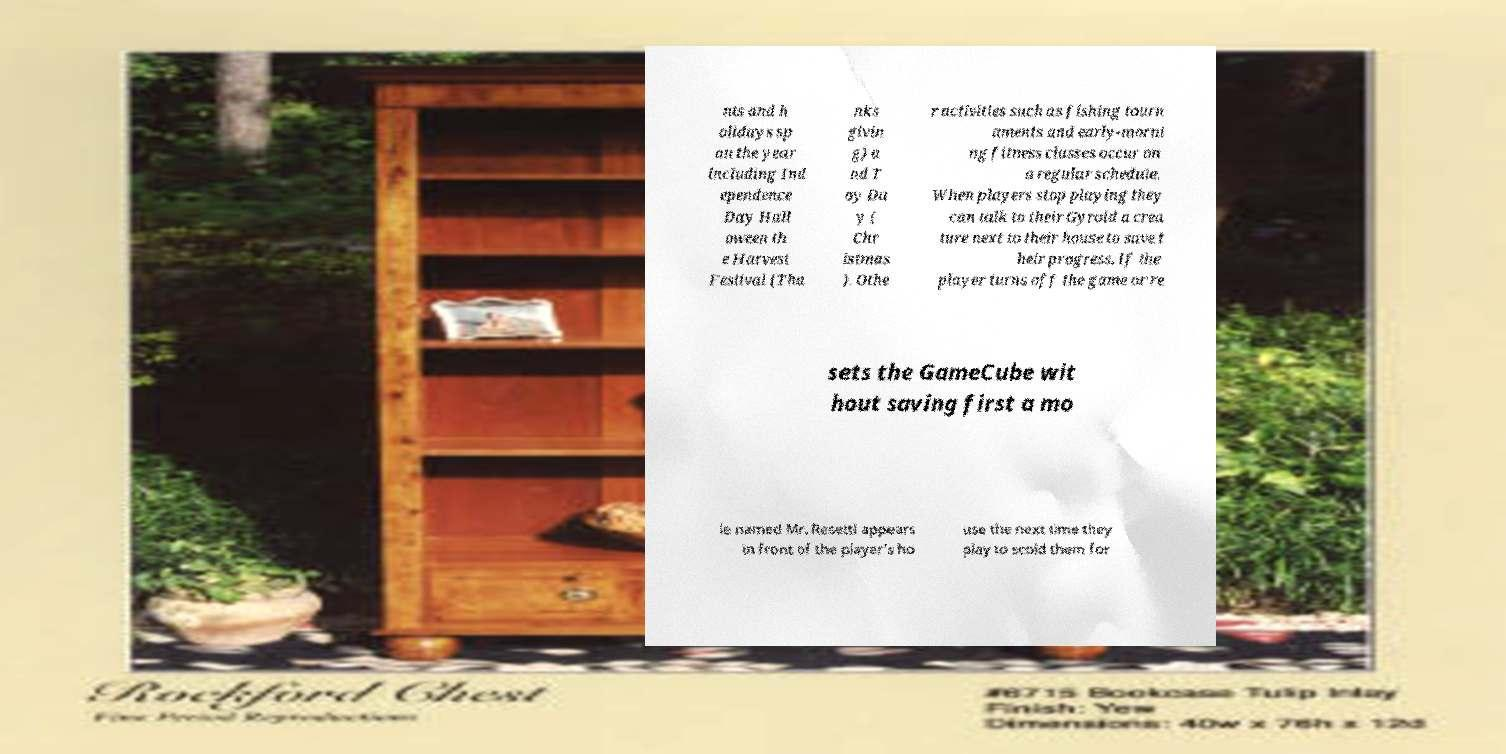Can you read and provide the text displayed in the image?This photo seems to have some interesting text. Can you extract and type it out for me? nts and h olidays sp an the year including Ind ependence Day Hall oween th e Harvest Festival (Tha nks givin g) a nd T oy Da y ( Chr istmas ). Othe r activities such as fishing tourn aments and early-morni ng fitness classes occur on a regular schedule. When players stop playing they can talk to their Gyroid a crea ture next to their house to save t heir progress. If the player turns off the game or re sets the GameCube wit hout saving first a mo le named Mr. Resetti appears in front of the player's ho use the next time they play to scold them for 